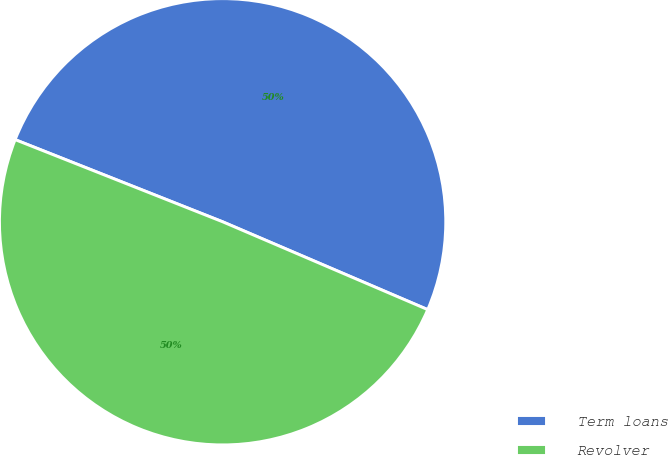Convert chart. <chart><loc_0><loc_0><loc_500><loc_500><pie_chart><fcel>Term loans<fcel>Revolver<nl><fcel>50.44%<fcel>49.56%<nl></chart> 